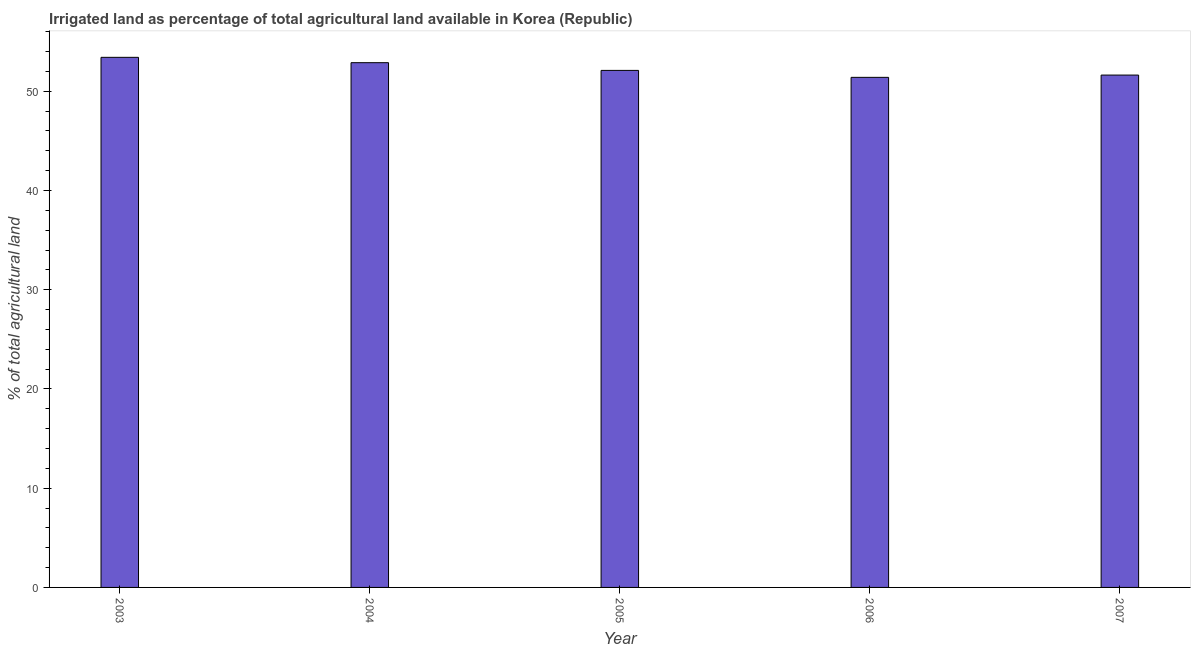Does the graph contain any zero values?
Provide a succinct answer. No. Does the graph contain grids?
Offer a very short reply. No. What is the title of the graph?
Your answer should be compact. Irrigated land as percentage of total agricultural land available in Korea (Republic). What is the label or title of the X-axis?
Your answer should be very brief. Year. What is the label or title of the Y-axis?
Give a very brief answer. % of total agricultural land. What is the percentage of agricultural irrigated land in 2005?
Keep it short and to the point. 52.1. Across all years, what is the maximum percentage of agricultural irrigated land?
Offer a terse response. 53.42. Across all years, what is the minimum percentage of agricultural irrigated land?
Keep it short and to the point. 51.4. In which year was the percentage of agricultural irrigated land maximum?
Offer a terse response. 2003. What is the sum of the percentage of agricultural irrigated land?
Your response must be concise. 261.43. What is the difference between the percentage of agricultural irrigated land in 2004 and 2007?
Your answer should be very brief. 1.25. What is the average percentage of agricultural irrigated land per year?
Your answer should be very brief. 52.28. What is the median percentage of agricultural irrigated land?
Offer a very short reply. 52.1. Is the percentage of agricultural irrigated land in 2003 less than that in 2007?
Your response must be concise. No. What is the difference between the highest and the second highest percentage of agricultural irrigated land?
Your answer should be very brief. 0.54. What is the difference between the highest and the lowest percentage of agricultural irrigated land?
Offer a terse response. 2.02. In how many years, is the percentage of agricultural irrigated land greater than the average percentage of agricultural irrigated land taken over all years?
Offer a very short reply. 2. How many bars are there?
Offer a terse response. 5. Are all the bars in the graph horizontal?
Give a very brief answer. No. What is the difference between two consecutive major ticks on the Y-axis?
Ensure brevity in your answer.  10. Are the values on the major ticks of Y-axis written in scientific E-notation?
Provide a short and direct response. No. What is the % of total agricultural land in 2003?
Give a very brief answer. 53.42. What is the % of total agricultural land of 2004?
Ensure brevity in your answer.  52.88. What is the % of total agricultural land of 2005?
Your answer should be very brief. 52.1. What is the % of total agricultural land in 2006?
Keep it short and to the point. 51.4. What is the % of total agricultural land of 2007?
Keep it short and to the point. 51.63. What is the difference between the % of total agricultural land in 2003 and 2004?
Provide a short and direct response. 0.54. What is the difference between the % of total agricultural land in 2003 and 2005?
Your answer should be compact. 1.32. What is the difference between the % of total agricultural land in 2003 and 2006?
Your answer should be compact. 2.02. What is the difference between the % of total agricultural land in 2003 and 2007?
Ensure brevity in your answer.  1.79. What is the difference between the % of total agricultural land in 2004 and 2005?
Provide a short and direct response. 0.78. What is the difference between the % of total agricultural land in 2004 and 2006?
Provide a short and direct response. 1.48. What is the difference between the % of total agricultural land in 2004 and 2007?
Your answer should be compact. 1.25. What is the difference between the % of total agricultural land in 2005 and 2006?
Provide a succinct answer. 0.7. What is the difference between the % of total agricultural land in 2005 and 2007?
Your answer should be very brief. 0.47. What is the difference between the % of total agricultural land in 2006 and 2007?
Give a very brief answer. -0.23. What is the ratio of the % of total agricultural land in 2003 to that in 2006?
Offer a terse response. 1.04. What is the ratio of the % of total agricultural land in 2003 to that in 2007?
Your answer should be compact. 1.03. What is the ratio of the % of total agricultural land in 2005 to that in 2006?
Your answer should be very brief. 1.01. 